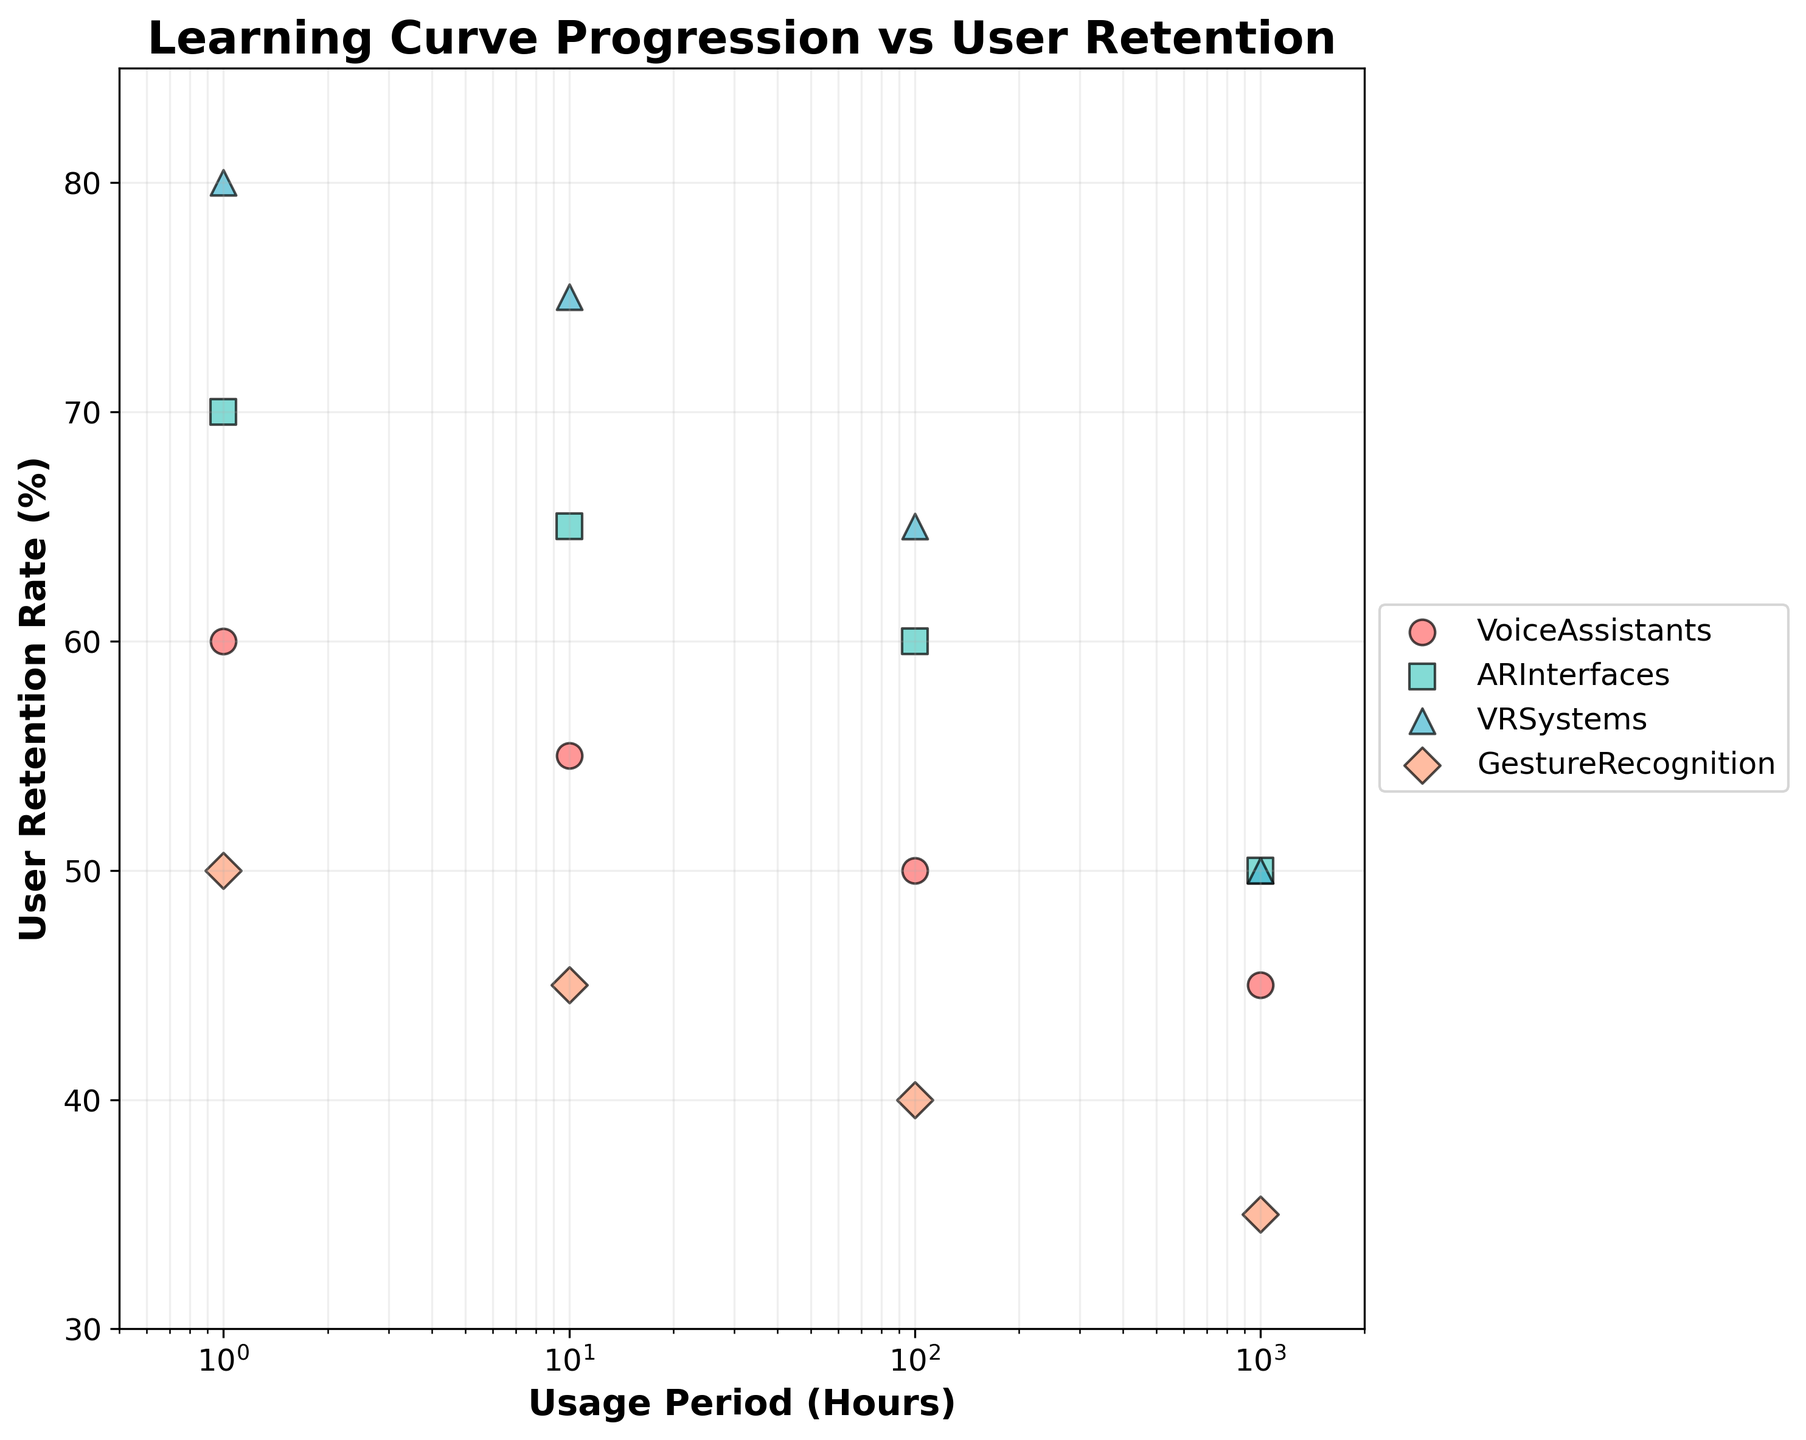What's the title of the figure? The title of the figure is the text located at the top which describes what the plot is about. In this plot, it is clearly written as the heading.
Answer: Learning Curve Progression vs User Retention What is the range of the Usage Period (Hours) on the x-axis? The x-axis is labeled "Usage Period (Hours)" and the data points show that it ranges from the smallest value to the highest evident value which are clearly marked. In the case of a log scale axis, the range is more apparent visually.
Answer: 0.5 to 2000 Which Interaction Tool has the highest User Retention Rate at 1 hour of usage? To find this, we look at the points corresponding to 1 hour on the x-axis and identify the highest point out of these on the y-axis, representing User Retention Rate.
Answer: VR Systems How does User Retention Rate change for Voice Assistants from 1 to 1000 hours? To answer, follow the trend of the data points for Voice Assistants from 1 to 1000 hours on the x-axis and observe the position on the y-axis representing the User Retention Rate.
Answer: The User Retention Rate decreases from 60% to 45% What is the difference in User Retention Rate between AR Interfaces and Gesture Recognition at 100 hours of usage? Identify the User Retention Rate for both AR Interfaces and Gesture Recognition at 100 hours of usage on the x-axis, then subtract the smaller rate from the larger. AR Interfaces is 60% and Gesture Recognition is 40%.
Answer: 20% Which Interaction Tool shows the least decrease in retention rate over 1000 hours? Observe the overall trend for each Interaction Tool from 1 hour to 1000 hours by comparing the starting and ending retention rates. The tool with the smallest drop is what we need.
Answer: VR Systems Between which two Usage Periods does AR Interfaces show the biggest drop in User Retention Rate? To determine this, compare the differences in User Retention Rate for AR Interfaces between consecutive usage periods: 1 to 10, 10 to 100, and 100 to 1000 hours. Find the largest drop.
Answer: 100 to 1000 hours Which Interaction Tool has no overlapping User Retention Rates with Gesture Recognition at any point on the usage period? Check the scatter points of Gesture Recognition and see if they overlap vertically (y-axis) with any other Interaction Tool. In this case, each point of Gesture Recognition doesn't vertically align with VR Systems across all x-axis values.
Answer: VR Systems 